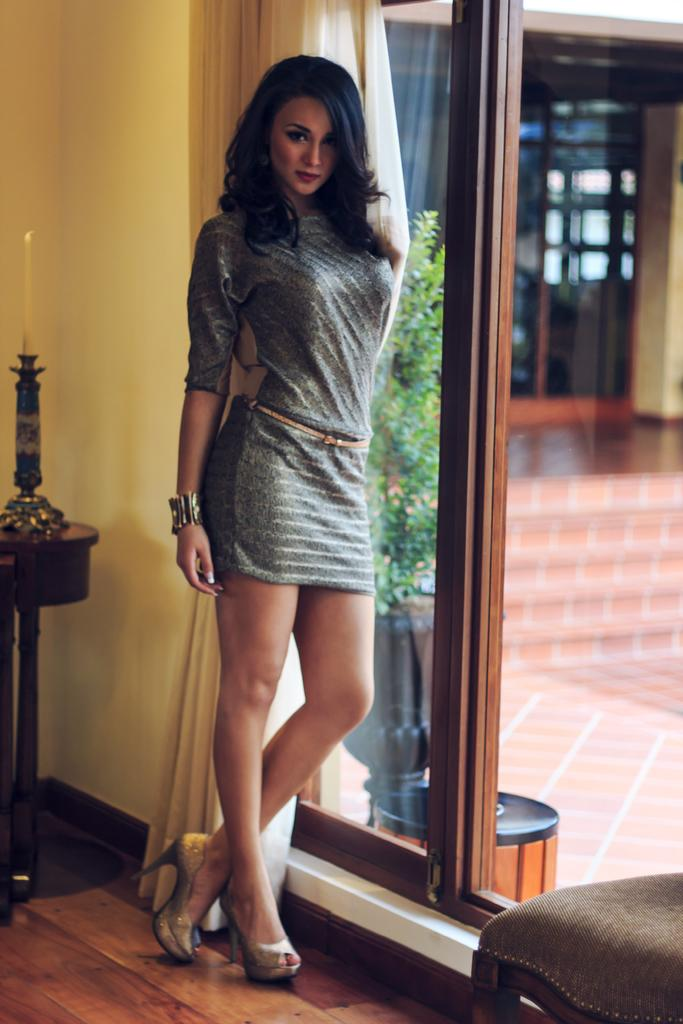What is the main subject of the image? There is a woman standing in the image. What object can be seen near the woman? There is a glass in the image. What type of window treatment is present in the image? There is a curtain in the image. What can be seen through the glass? A plant is visible through the glass. What is on the table in the image? There is a candle on a table in the image. What type of background is visible in the image? There is a wall visible in the image. How many fifths are present in the image? There is no reference to a fifth or any fraction in the image, so it is not possible to answer that question. 